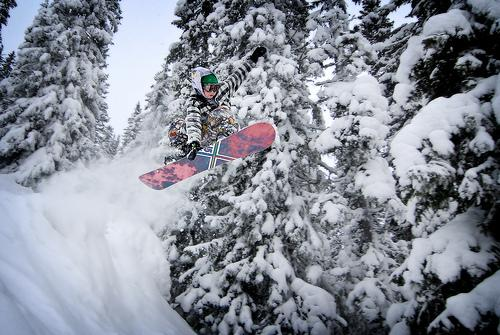Analyze the interaction between the person and the snowboard in the image. The person is holding the snowboard with their right hand, and they are on top of it while doing a jump, with white snow plume behind them. From the given information, describe the weather in the image. The image likely depicts a snowy, cold day with snow covering the ground and trees. What is the primary activity happening in the picture? A person is snowboarding and doing a jump. Count the number of snow-covered trees in the image. There are numerous snowy trees in the background. List the three key objects in the image and their colors. Person with a plaid coat, red and black snowboard, and green baseball cap. What type of headgear is the person wearing, and what is its color? The person is wearing a green baseball cap and ski goggles. Assess any potential dangers or risks present in the image. There may be a risk of injury from the snowboarder jumping and potential for a fall. Provide a brief description of the snowboard design in the image. The snowboard is red and black with a colorful X design underneath. Mention the color and pattern of the person's jacket in the image. The person is wearing a black and white plaid coat. Describe one detail about the trees and one detail about the sky in the image. There are tall, snow-covered evergreen trees and a blue sky behind them. 